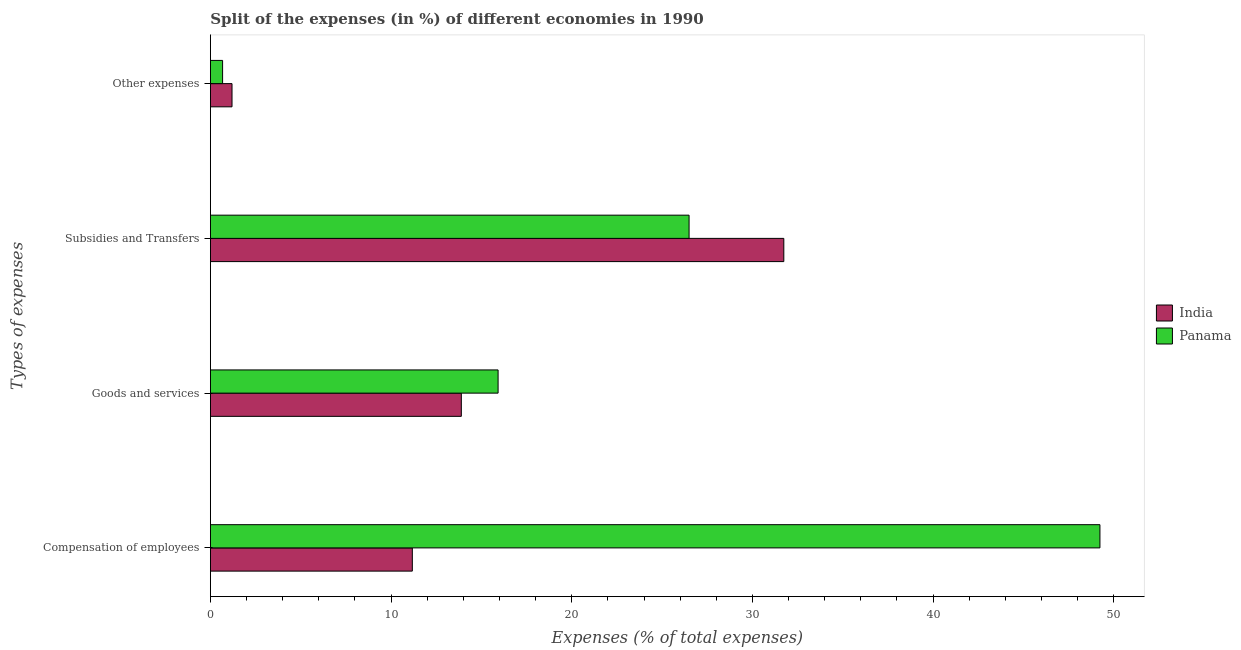Are the number of bars per tick equal to the number of legend labels?
Make the answer very short. Yes. Are the number of bars on each tick of the Y-axis equal?
Your answer should be very brief. Yes. What is the label of the 1st group of bars from the top?
Give a very brief answer. Other expenses. What is the percentage of amount spent on subsidies in India?
Offer a terse response. 31.74. Across all countries, what is the maximum percentage of amount spent on other expenses?
Give a very brief answer. 1.2. Across all countries, what is the minimum percentage of amount spent on compensation of employees?
Offer a very short reply. 11.18. What is the total percentage of amount spent on subsidies in the graph?
Make the answer very short. 58.23. What is the difference between the percentage of amount spent on compensation of employees in Panama and that in India?
Offer a terse response. 38.06. What is the difference between the percentage of amount spent on goods and services in Panama and the percentage of amount spent on other expenses in India?
Provide a short and direct response. 14.73. What is the average percentage of amount spent on goods and services per country?
Your response must be concise. 14.91. What is the difference between the percentage of amount spent on compensation of employees and percentage of amount spent on subsidies in India?
Ensure brevity in your answer.  -20.56. What is the ratio of the percentage of amount spent on goods and services in India to that in Panama?
Make the answer very short. 0.87. Is the percentage of amount spent on goods and services in India less than that in Panama?
Give a very brief answer. Yes. Is the difference between the percentage of amount spent on other expenses in India and Panama greater than the difference between the percentage of amount spent on goods and services in India and Panama?
Offer a very short reply. Yes. What is the difference between the highest and the second highest percentage of amount spent on subsidies?
Give a very brief answer. 5.24. What is the difference between the highest and the lowest percentage of amount spent on subsidies?
Make the answer very short. 5.24. Is the sum of the percentage of amount spent on goods and services in India and Panama greater than the maximum percentage of amount spent on other expenses across all countries?
Provide a short and direct response. Yes. What does the 2nd bar from the top in Other expenses represents?
Make the answer very short. India. What does the 2nd bar from the bottom in Compensation of employees represents?
Give a very brief answer. Panama. How many bars are there?
Keep it short and to the point. 8. Are all the bars in the graph horizontal?
Give a very brief answer. Yes. How many countries are there in the graph?
Offer a very short reply. 2. What is the difference between two consecutive major ticks on the X-axis?
Offer a terse response. 10. Does the graph contain grids?
Ensure brevity in your answer.  No. How are the legend labels stacked?
Your answer should be very brief. Vertical. What is the title of the graph?
Your response must be concise. Split of the expenses (in %) of different economies in 1990. What is the label or title of the X-axis?
Provide a succinct answer. Expenses (% of total expenses). What is the label or title of the Y-axis?
Make the answer very short. Types of expenses. What is the Expenses (% of total expenses) of India in Compensation of employees?
Your answer should be very brief. 11.18. What is the Expenses (% of total expenses) of Panama in Compensation of employees?
Offer a very short reply. 49.23. What is the Expenses (% of total expenses) in India in Goods and services?
Keep it short and to the point. 13.89. What is the Expenses (% of total expenses) in Panama in Goods and services?
Keep it short and to the point. 15.92. What is the Expenses (% of total expenses) of India in Subsidies and Transfers?
Keep it short and to the point. 31.74. What is the Expenses (% of total expenses) of Panama in Subsidies and Transfers?
Offer a very short reply. 26.49. What is the Expenses (% of total expenses) in India in Other expenses?
Your answer should be very brief. 1.2. What is the Expenses (% of total expenses) in Panama in Other expenses?
Give a very brief answer. 0.68. Across all Types of expenses, what is the maximum Expenses (% of total expenses) of India?
Ensure brevity in your answer.  31.74. Across all Types of expenses, what is the maximum Expenses (% of total expenses) of Panama?
Keep it short and to the point. 49.23. Across all Types of expenses, what is the minimum Expenses (% of total expenses) of India?
Keep it short and to the point. 1.2. Across all Types of expenses, what is the minimum Expenses (% of total expenses) in Panama?
Make the answer very short. 0.68. What is the total Expenses (% of total expenses) of India in the graph?
Your answer should be very brief. 58. What is the total Expenses (% of total expenses) of Panama in the graph?
Make the answer very short. 92.32. What is the difference between the Expenses (% of total expenses) of India in Compensation of employees and that in Goods and services?
Offer a very short reply. -2.71. What is the difference between the Expenses (% of total expenses) of Panama in Compensation of employees and that in Goods and services?
Provide a short and direct response. 33.31. What is the difference between the Expenses (% of total expenses) in India in Compensation of employees and that in Subsidies and Transfers?
Your answer should be very brief. -20.56. What is the difference between the Expenses (% of total expenses) of Panama in Compensation of employees and that in Subsidies and Transfers?
Your answer should be compact. 22.74. What is the difference between the Expenses (% of total expenses) in India in Compensation of employees and that in Other expenses?
Your answer should be compact. 9.98. What is the difference between the Expenses (% of total expenses) in Panama in Compensation of employees and that in Other expenses?
Offer a very short reply. 48.56. What is the difference between the Expenses (% of total expenses) in India in Goods and services and that in Subsidies and Transfers?
Provide a short and direct response. -17.85. What is the difference between the Expenses (% of total expenses) of Panama in Goods and services and that in Subsidies and Transfers?
Provide a succinct answer. -10.57. What is the difference between the Expenses (% of total expenses) of India in Goods and services and that in Other expenses?
Provide a succinct answer. 12.69. What is the difference between the Expenses (% of total expenses) in Panama in Goods and services and that in Other expenses?
Make the answer very short. 15.25. What is the difference between the Expenses (% of total expenses) in India in Subsidies and Transfers and that in Other expenses?
Keep it short and to the point. 30.54. What is the difference between the Expenses (% of total expenses) in Panama in Subsidies and Transfers and that in Other expenses?
Offer a very short reply. 25.82. What is the difference between the Expenses (% of total expenses) of India in Compensation of employees and the Expenses (% of total expenses) of Panama in Goods and services?
Your answer should be very brief. -4.75. What is the difference between the Expenses (% of total expenses) in India in Compensation of employees and the Expenses (% of total expenses) in Panama in Subsidies and Transfers?
Your answer should be very brief. -15.32. What is the difference between the Expenses (% of total expenses) of India in Compensation of employees and the Expenses (% of total expenses) of Panama in Other expenses?
Give a very brief answer. 10.5. What is the difference between the Expenses (% of total expenses) in India in Goods and services and the Expenses (% of total expenses) in Panama in Subsidies and Transfers?
Keep it short and to the point. -12.61. What is the difference between the Expenses (% of total expenses) of India in Goods and services and the Expenses (% of total expenses) of Panama in Other expenses?
Your answer should be very brief. 13.21. What is the difference between the Expenses (% of total expenses) of India in Subsidies and Transfers and the Expenses (% of total expenses) of Panama in Other expenses?
Offer a terse response. 31.06. What is the average Expenses (% of total expenses) in India per Types of expenses?
Offer a terse response. 14.5. What is the average Expenses (% of total expenses) in Panama per Types of expenses?
Your response must be concise. 23.08. What is the difference between the Expenses (% of total expenses) of India and Expenses (% of total expenses) of Panama in Compensation of employees?
Give a very brief answer. -38.06. What is the difference between the Expenses (% of total expenses) of India and Expenses (% of total expenses) of Panama in Goods and services?
Keep it short and to the point. -2.04. What is the difference between the Expenses (% of total expenses) of India and Expenses (% of total expenses) of Panama in Subsidies and Transfers?
Your answer should be very brief. 5.24. What is the difference between the Expenses (% of total expenses) in India and Expenses (% of total expenses) in Panama in Other expenses?
Provide a short and direct response. 0.52. What is the ratio of the Expenses (% of total expenses) in India in Compensation of employees to that in Goods and services?
Your response must be concise. 0.8. What is the ratio of the Expenses (% of total expenses) in Panama in Compensation of employees to that in Goods and services?
Provide a short and direct response. 3.09. What is the ratio of the Expenses (% of total expenses) of India in Compensation of employees to that in Subsidies and Transfers?
Keep it short and to the point. 0.35. What is the ratio of the Expenses (% of total expenses) in Panama in Compensation of employees to that in Subsidies and Transfers?
Offer a very short reply. 1.86. What is the ratio of the Expenses (% of total expenses) of India in Compensation of employees to that in Other expenses?
Ensure brevity in your answer.  9.34. What is the ratio of the Expenses (% of total expenses) in Panama in Compensation of employees to that in Other expenses?
Provide a succinct answer. 72.92. What is the ratio of the Expenses (% of total expenses) in India in Goods and services to that in Subsidies and Transfers?
Your answer should be very brief. 0.44. What is the ratio of the Expenses (% of total expenses) in Panama in Goods and services to that in Subsidies and Transfers?
Your answer should be very brief. 0.6. What is the ratio of the Expenses (% of total expenses) of India in Goods and services to that in Other expenses?
Provide a short and direct response. 11.6. What is the ratio of the Expenses (% of total expenses) in Panama in Goods and services to that in Other expenses?
Offer a terse response. 23.58. What is the ratio of the Expenses (% of total expenses) of India in Subsidies and Transfers to that in Other expenses?
Make the answer very short. 26.51. What is the ratio of the Expenses (% of total expenses) of Panama in Subsidies and Transfers to that in Other expenses?
Your response must be concise. 39.24. What is the difference between the highest and the second highest Expenses (% of total expenses) of India?
Offer a very short reply. 17.85. What is the difference between the highest and the second highest Expenses (% of total expenses) of Panama?
Keep it short and to the point. 22.74. What is the difference between the highest and the lowest Expenses (% of total expenses) in India?
Your answer should be compact. 30.54. What is the difference between the highest and the lowest Expenses (% of total expenses) of Panama?
Ensure brevity in your answer.  48.56. 